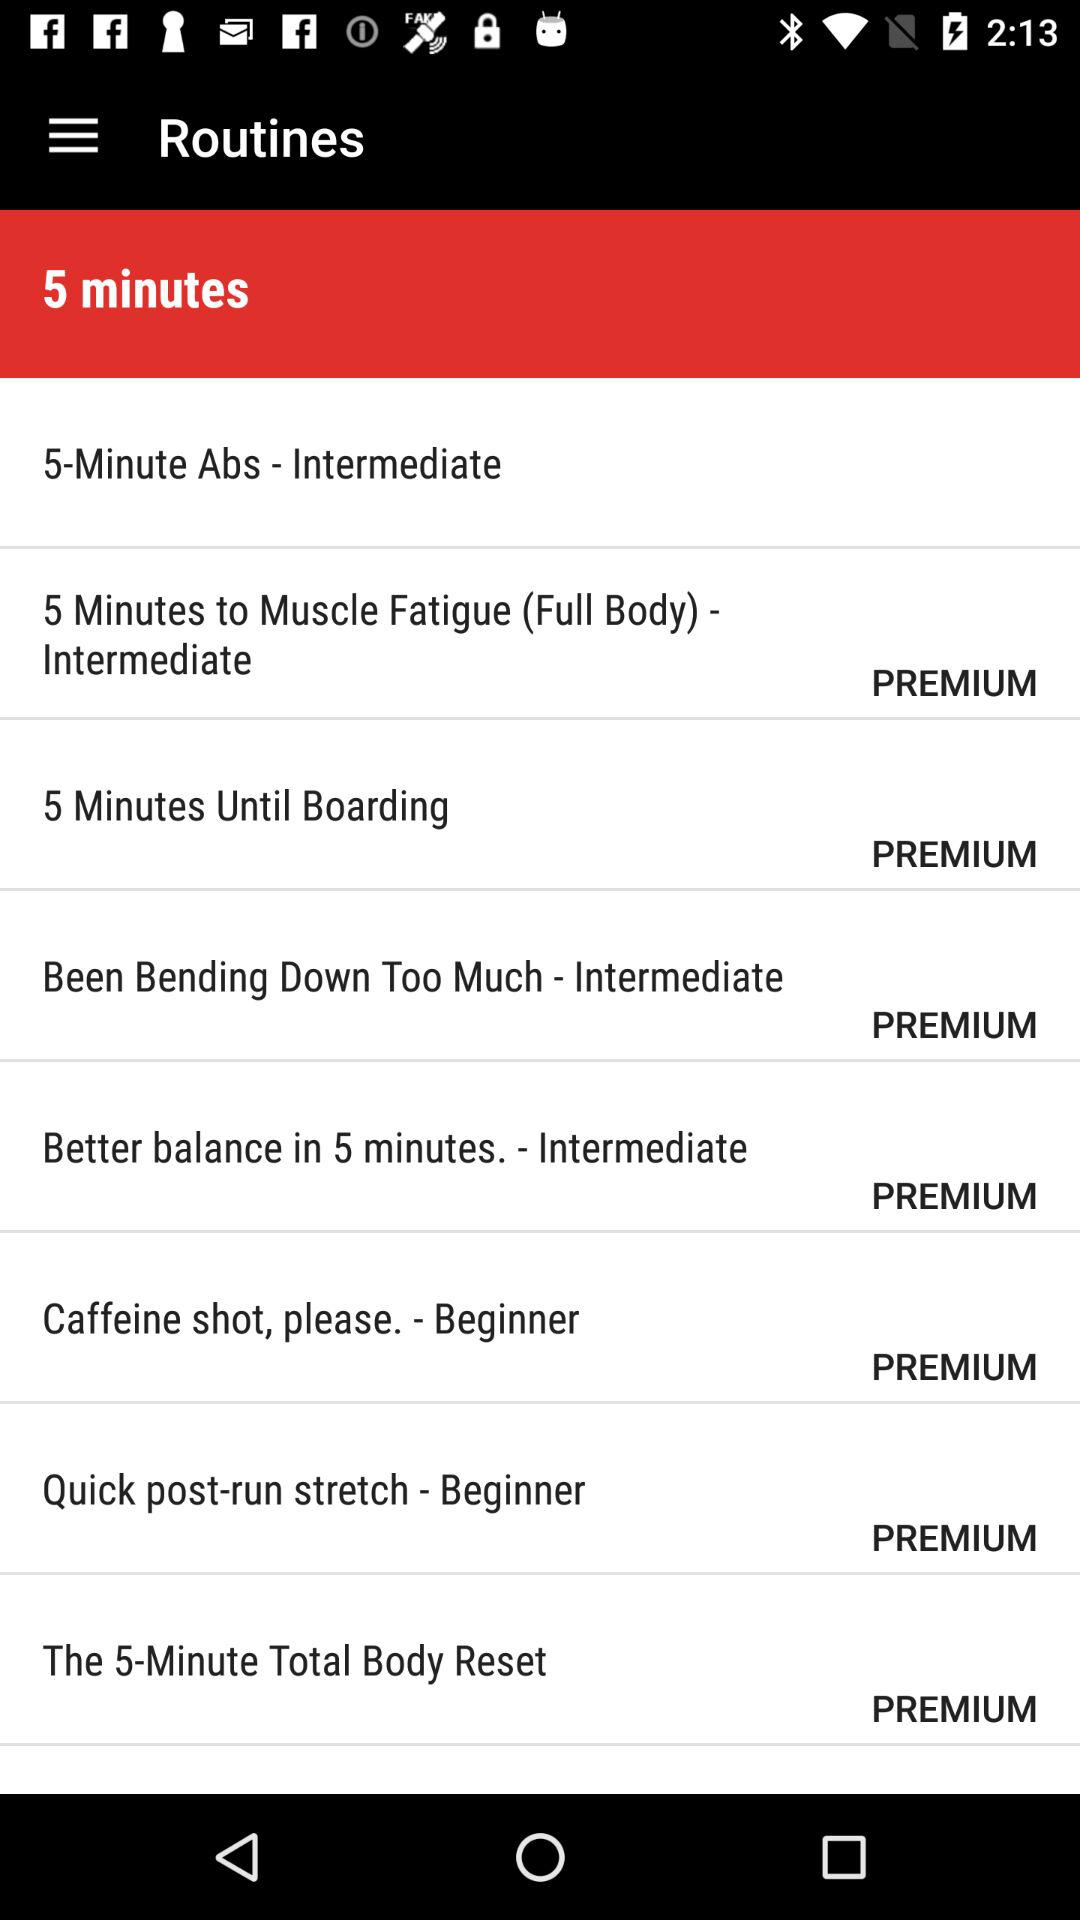Which stage is there of "Caffeine shot, please."?
Answer the question using a single word or phrase. There is a beginner stage of "Caffeine shot, please." 